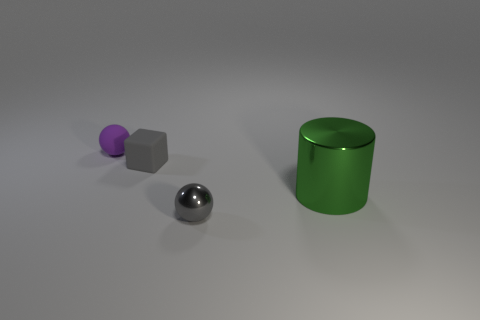Add 2 large green shiny cylinders. How many objects exist? 6 Subtract all purple spheres. How many spheres are left? 1 Subtract 1 balls. How many balls are left? 1 Subtract 0 blue cubes. How many objects are left? 4 Subtract all blocks. How many objects are left? 3 Subtract all blue cylinders. Subtract all cyan spheres. How many cylinders are left? 1 Subtract all blue cylinders. How many gray spheres are left? 1 Subtract all tiny cubes. Subtract all gray objects. How many objects are left? 1 Add 1 tiny gray cubes. How many tiny gray cubes are left? 2 Add 1 green rubber spheres. How many green rubber spheres exist? 1 